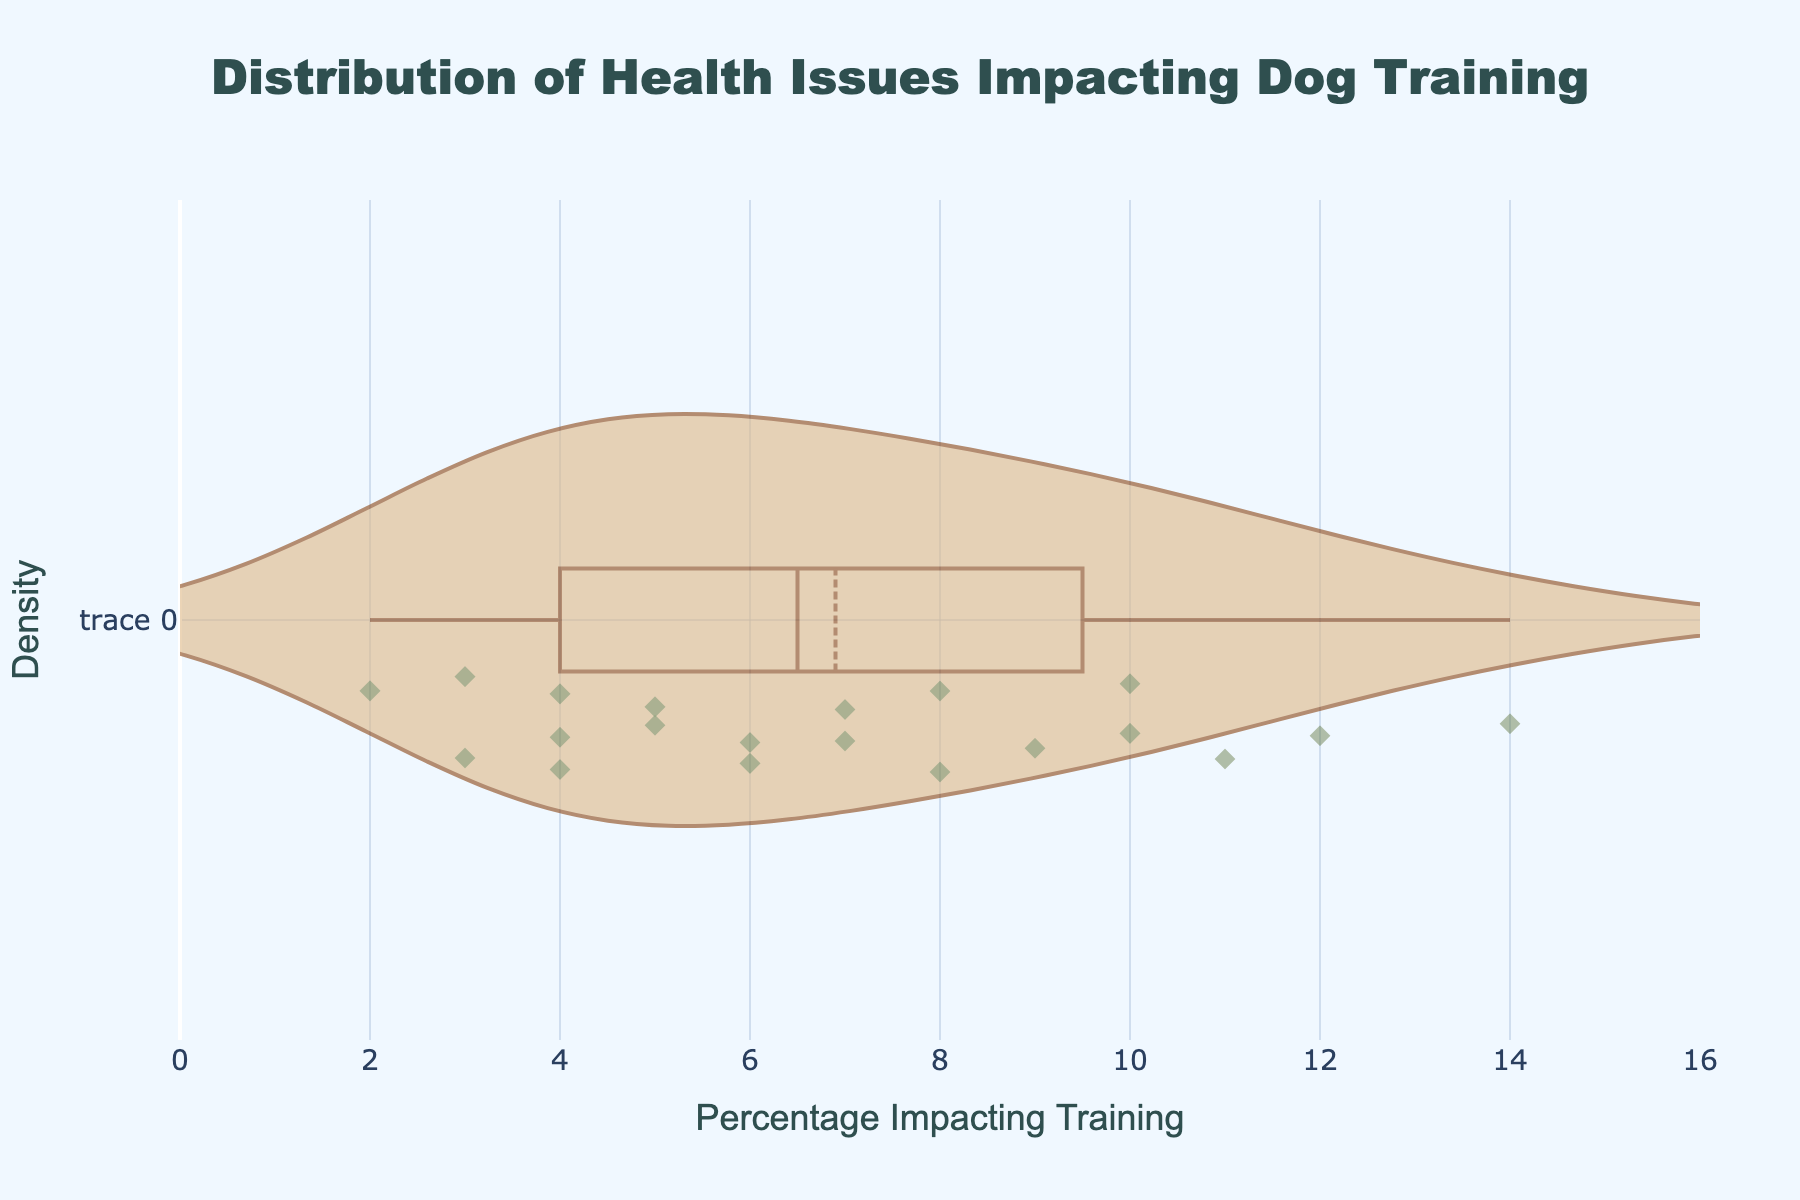What is the title of the plot? The title is typically found at the top of the plot.
Answer: Distribution of Health Issues Impacting Dog Training What is the range of the x-axis? The x-axis range spans from 0 to the maximum value of the data points plus an additional 2 units, which is 0 to 16.
Answer: 0 to 16 What is the mean percentage of health issues impacting training? The mean percentage is marked with a visible line within the violin plot.
Answer: 7 How many data points are represented in the plot? Each data point is marked by a diamond-shaped marker. Count the markers to get the number of data points. There are 20 markers.
Answer: 20 Which dog breed has the highest percentage impacting training in the plot? By identifying the maximum percentage value on the x-axis, we can see the corresponding breed. French Bulldog has the highest percentage at 14%.
Answer: French Bulldog What is the median percentage of health issues impacting training? The median is the middle value when the percentages are ordered. The plot's meanline also shows the median value.
Answer: 7 What is the lowest percentage impacting training seen in the plot? The lowest percentage is the minimum value on the x-axis, observed as 2%.
Answer: 2 Which breeds have a percentage impacting training greater than 10%? Identify the data points on the x-axis with values greater than 10. Bulldogs (12%), Pug (11%), and French Bulldogs (14%).
Answer: Bulldogs, Pug, French Bulldogs Which dog breeds fall between 5% and 7% in the percentage impacting training? Identify the data points on the x-axis between 5% and 7%. Golden Retriever (7%), Yorkshire Terrier (5%), Shih Tzu (6%), Cocker Spaniel (5%), Boxer (6%), and Chihuahua (7%).
Answer: Golden Retriever, Yorkshire Terrier, Shih Tzu, Cocker Spaniel, Boxer, Chihuahua How many breeds have health issues impacting training at exactly 4%? Count the data points on the x-axis at the 4% mark. There are 3 breeds with 4%: Beagle, Siberian Husky, and Australian Shepherd.
Answer: 3 